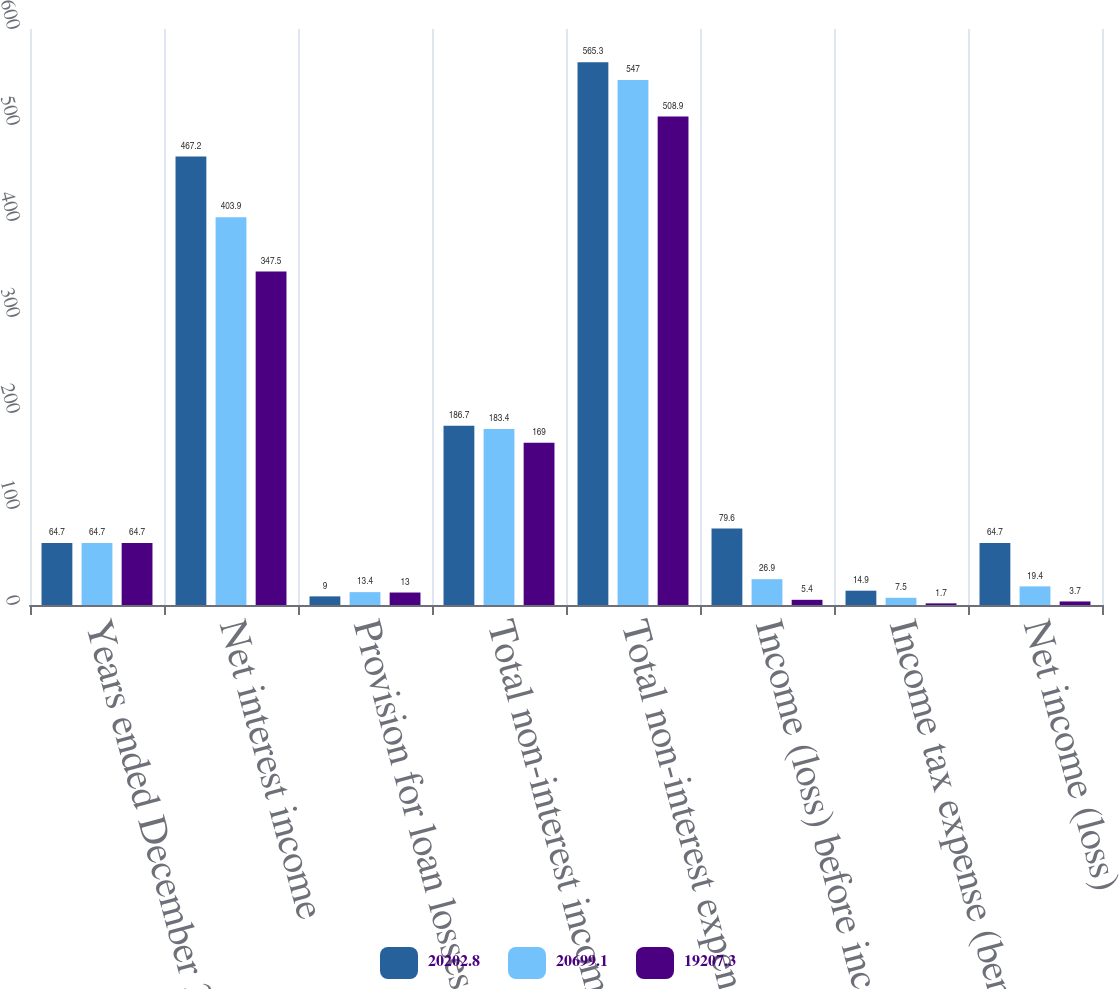<chart> <loc_0><loc_0><loc_500><loc_500><stacked_bar_chart><ecel><fcel>Years ended December 31 (in<fcel>Net interest income<fcel>Provision for loan losses<fcel>Total non-interest income<fcel>Total non-interest expense<fcel>Income (loss) before income<fcel>Income tax expense (benefit)<fcel>Net income (loss)<nl><fcel>20202.8<fcel>64.7<fcel>467.2<fcel>9<fcel>186.7<fcel>565.3<fcel>79.6<fcel>14.9<fcel>64.7<nl><fcel>20699.1<fcel>64.7<fcel>403.9<fcel>13.4<fcel>183.4<fcel>547<fcel>26.9<fcel>7.5<fcel>19.4<nl><fcel>19207.3<fcel>64.7<fcel>347.5<fcel>13<fcel>169<fcel>508.9<fcel>5.4<fcel>1.7<fcel>3.7<nl></chart> 